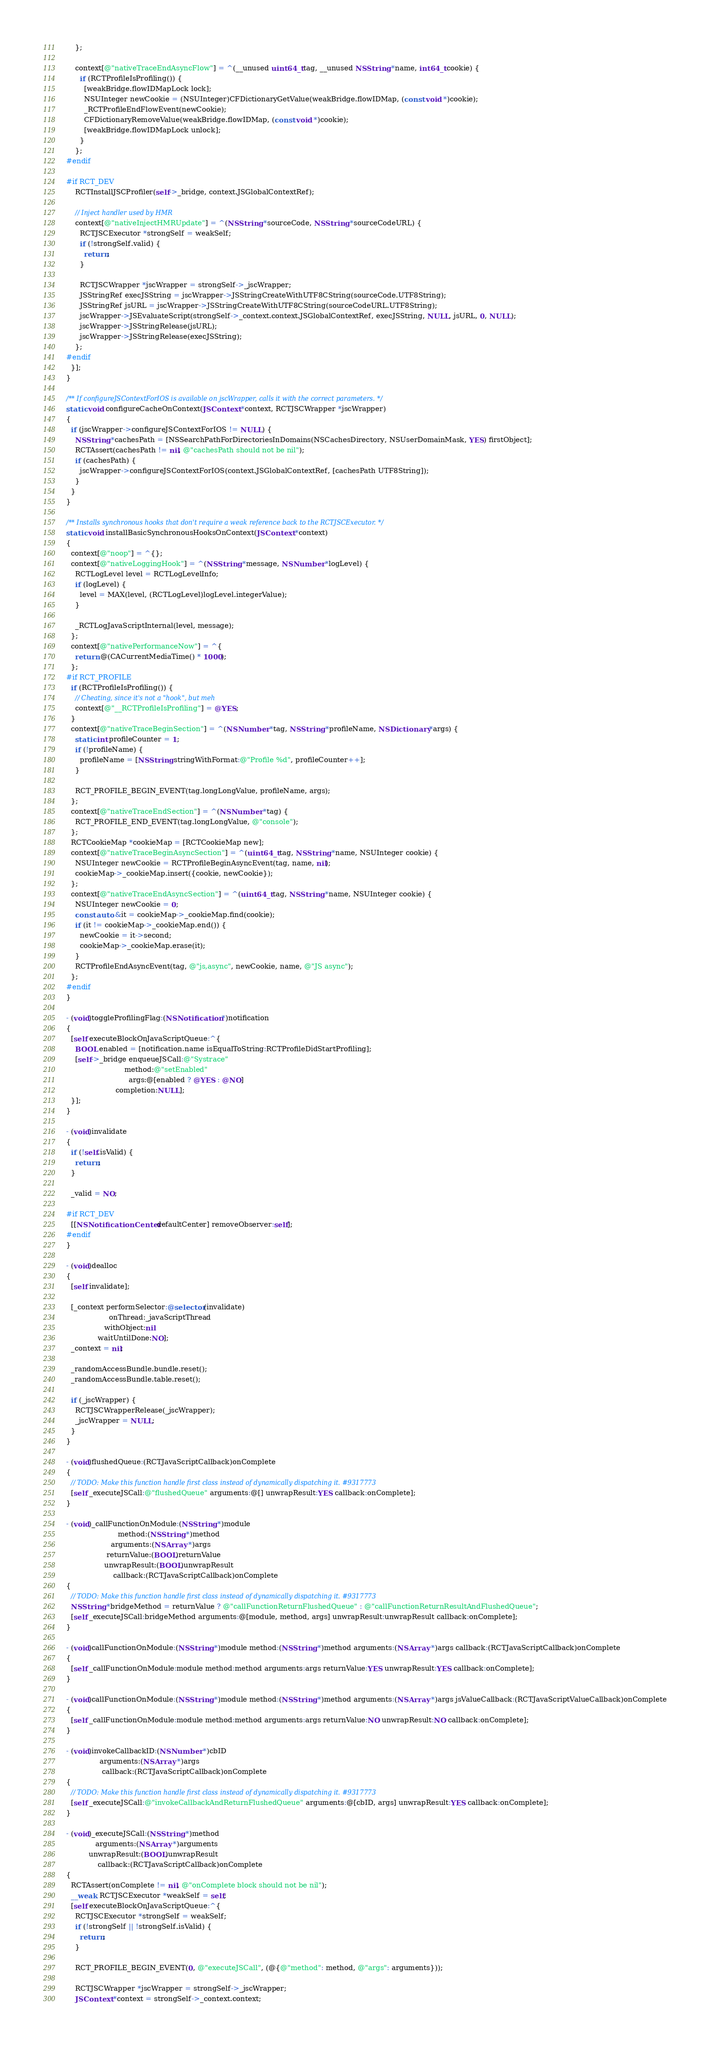<code> <loc_0><loc_0><loc_500><loc_500><_ObjectiveC_>    };

    context[@"nativeTraceEndAsyncFlow"] = ^(__unused uint64_t tag, __unused NSString *name, int64_t cookie) {
      if (RCTProfileIsProfiling()) {
        [weakBridge.flowIDMapLock lock];
        NSUInteger newCookie = (NSUInteger)CFDictionaryGetValue(weakBridge.flowIDMap, (const void *)cookie);
        _RCTProfileEndFlowEvent(newCookie);
        CFDictionaryRemoveValue(weakBridge.flowIDMap, (const void *)cookie);
        [weakBridge.flowIDMapLock unlock];
      }
    };
#endif

#if RCT_DEV
    RCTInstallJSCProfiler(self->_bridge, context.JSGlobalContextRef);

    // Inject handler used by HMR
    context[@"nativeInjectHMRUpdate"] = ^(NSString *sourceCode, NSString *sourceCodeURL) {
      RCTJSCExecutor *strongSelf = weakSelf;
      if (!strongSelf.valid) {
        return;
      }

      RCTJSCWrapper *jscWrapper = strongSelf->_jscWrapper;
      JSStringRef execJSString = jscWrapper->JSStringCreateWithUTF8CString(sourceCode.UTF8String);
      JSStringRef jsURL = jscWrapper->JSStringCreateWithUTF8CString(sourceCodeURL.UTF8String);
      jscWrapper->JSEvaluateScript(strongSelf->_context.context.JSGlobalContextRef, execJSString, NULL, jsURL, 0, NULL);
      jscWrapper->JSStringRelease(jsURL);
      jscWrapper->JSStringRelease(execJSString);
    };
#endif
  }];
}

/** If configureJSContextForIOS is available on jscWrapper, calls it with the correct parameters. */
static void configureCacheOnContext(JSContext *context, RCTJSCWrapper *jscWrapper)
{
  if (jscWrapper->configureJSContextForIOS != NULL) {
    NSString *cachesPath = [NSSearchPathForDirectoriesInDomains(NSCachesDirectory, NSUserDomainMask, YES) firstObject];
    RCTAssert(cachesPath != nil, @"cachesPath should not be nil");
    if (cachesPath) {
      jscWrapper->configureJSContextForIOS(context.JSGlobalContextRef, [cachesPath UTF8String]);
    }
  }
}

/** Installs synchronous hooks that don't require a weak reference back to the RCTJSCExecutor. */
static void installBasicSynchronousHooksOnContext(JSContext *context)
{
  context[@"noop"] = ^{};
  context[@"nativeLoggingHook"] = ^(NSString *message, NSNumber *logLevel) {
    RCTLogLevel level = RCTLogLevelInfo;
    if (logLevel) {
      level = MAX(level, (RCTLogLevel)logLevel.integerValue);
    }

    _RCTLogJavaScriptInternal(level, message);
  };
  context[@"nativePerformanceNow"] = ^{
    return @(CACurrentMediaTime() * 1000);
  };
#if RCT_PROFILE
  if (RCTProfileIsProfiling()) {
    // Cheating, since it's not a "hook", but meh
    context[@"__RCTProfileIsProfiling"] = @YES;
  }
  context[@"nativeTraceBeginSection"] = ^(NSNumber *tag, NSString *profileName, NSDictionary *args) {
    static int profileCounter = 1;
    if (!profileName) {
      profileName = [NSString stringWithFormat:@"Profile %d", profileCounter++];
    }

    RCT_PROFILE_BEGIN_EVENT(tag.longLongValue, profileName, args);
  };
  context[@"nativeTraceEndSection"] = ^(NSNumber *tag) {
    RCT_PROFILE_END_EVENT(tag.longLongValue, @"console");
  };
  RCTCookieMap *cookieMap = [RCTCookieMap new];
  context[@"nativeTraceBeginAsyncSection"] = ^(uint64_t tag, NSString *name, NSUInteger cookie) {
    NSUInteger newCookie = RCTProfileBeginAsyncEvent(tag, name, nil);
    cookieMap->_cookieMap.insert({cookie, newCookie});
  };
  context[@"nativeTraceEndAsyncSection"] = ^(uint64_t tag, NSString *name, NSUInteger cookie) {
    NSUInteger newCookie = 0;
    const auto &it = cookieMap->_cookieMap.find(cookie);
    if (it != cookieMap->_cookieMap.end()) {
      newCookie = it->second;
      cookieMap->_cookieMap.erase(it);
    }
    RCTProfileEndAsyncEvent(tag, @"js,async", newCookie, name, @"JS async");
  };
#endif
}

- (void)toggleProfilingFlag:(NSNotification *)notification
{
  [self executeBlockOnJavaScriptQueue:^{
    BOOL enabled = [notification.name isEqualToString:RCTProfileDidStartProfiling];
    [self->_bridge enqueueJSCall:@"Systrace"
                          method:@"setEnabled"
                            args:@[enabled ? @YES : @NO]
                      completion:NULL];
  }];
}

- (void)invalidate
{
  if (!self.isValid) {
    return;
  }

  _valid = NO;

#if RCT_DEV
  [[NSNotificationCenter defaultCenter] removeObserver:self];
#endif
}

- (void)dealloc
{
  [self invalidate];

  [_context performSelector:@selector(invalidate)
                   onThread:_javaScriptThread
                 withObject:nil
              waitUntilDone:NO];
  _context = nil;

  _randomAccessBundle.bundle.reset();
  _randomAccessBundle.table.reset();

  if (_jscWrapper) {
    RCTJSCWrapperRelease(_jscWrapper);
    _jscWrapper = NULL;
  }
}

- (void)flushedQueue:(RCTJavaScriptCallback)onComplete
{
  // TODO: Make this function handle first class instead of dynamically dispatching it. #9317773
  [self _executeJSCall:@"flushedQueue" arguments:@[] unwrapResult:YES callback:onComplete];
}

- (void)_callFunctionOnModule:(NSString *)module
                       method:(NSString *)method
                    arguments:(NSArray *)args
                  returnValue:(BOOL)returnValue
                 unwrapResult:(BOOL)unwrapResult
                     callback:(RCTJavaScriptCallback)onComplete
{
  // TODO: Make this function handle first class instead of dynamically dispatching it. #9317773
  NSString *bridgeMethod = returnValue ? @"callFunctionReturnFlushedQueue" : @"callFunctionReturnResultAndFlushedQueue";
  [self _executeJSCall:bridgeMethod arguments:@[module, method, args] unwrapResult:unwrapResult callback:onComplete];
}

- (void)callFunctionOnModule:(NSString *)module method:(NSString *)method arguments:(NSArray *)args callback:(RCTJavaScriptCallback)onComplete
{
  [self _callFunctionOnModule:module method:method arguments:args returnValue:YES unwrapResult:YES callback:onComplete];
}

- (void)callFunctionOnModule:(NSString *)module method:(NSString *)method arguments:(NSArray *)args jsValueCallback:(RCTJavaScriptValueCallback)onComplete
{
  [self _callFunctionOnModule:module method:method arguments:args returnValue:NO unwrapResult:NO callback:onComplete];
}

- (void)invokeCallbackID:(NSNumber *)cbID
               arguments:(NSArray *)args
                callback:(RCTJavaScriptCallback)onComplete
{
  // TODO: Make this function handle first class instead of dynamically dispatching it. #9317773
  [self _executeJSCall:@"invokeCallbackAndReturnFlushedQueue" arguments:@[cbID, args] unwrapResult:YES callback:onComplete];
}

- (void)_executeJSCall:(NSString *)method
             arguments:(NSArray *)arguments
          unwrapResult:(BOOL)unwrapResult
              callback:(RCTJavaScriptCallback)onComplete
{
  RCTAssert(onComplete != nil, @"onComplete block should not be nil");
  __weak RCTJSCExecutor *weakSelf = self;
  [self executeBlockOnJavaScriptQueue:^{
    RCTJSCExecutor *strongSelf = weakSelf;
    if (!strongSelf || !strongSelf.isValid) {
      return;
    }

    RCT_PROFILE_BEGIN_EVENT(0, @"executeJSCall", (@{@"method": method, @"args": arguments}));

    RCTJSCWrapper *jscWrapper = strongSelf->_jscWrapper;
    JSContext *context = strongSelf->_context.context;</code> 